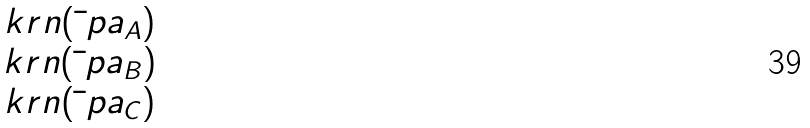Convert formula to latex. <formula><loc_0><loc_0><loc_500><loc_500>\begin{matrix} \ k r n ( \bar { \ } p a _ { A } ) \\ \ k r n ( \bar { \ } p a _ { B } ) \\ \ k r n ( \bar { \ } p a _ { C } ) \end{matrix}</formula> 